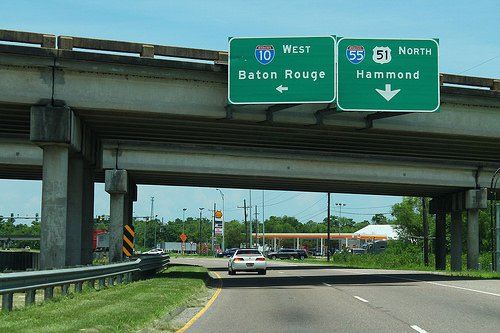<image>
Can you confirm if the board is above the grass? Yes. The board is positioned above the grass in the vertical space, higher up in the scene. 